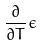Convert formula to latex. <formula><loc_0><loc_0><loc_500><loc_500>\frac { \partial } { \partial T } \epsilon</formula> 